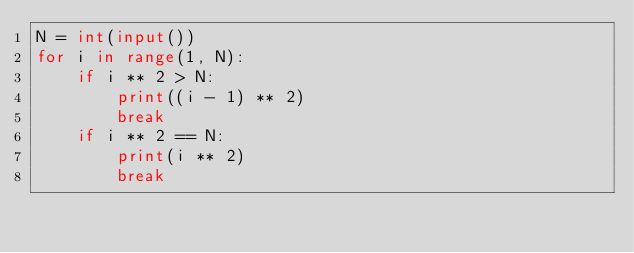<code> <loc_0><loc_0><loc_500><loc_500><_Python_>N = int(input())
for i in range(1, N):
    if i ** 2 > N:
        print((i - 1) ** 2)
        break
    if i ** 2 == N:
        print(i ** 2)
        break
</code> 